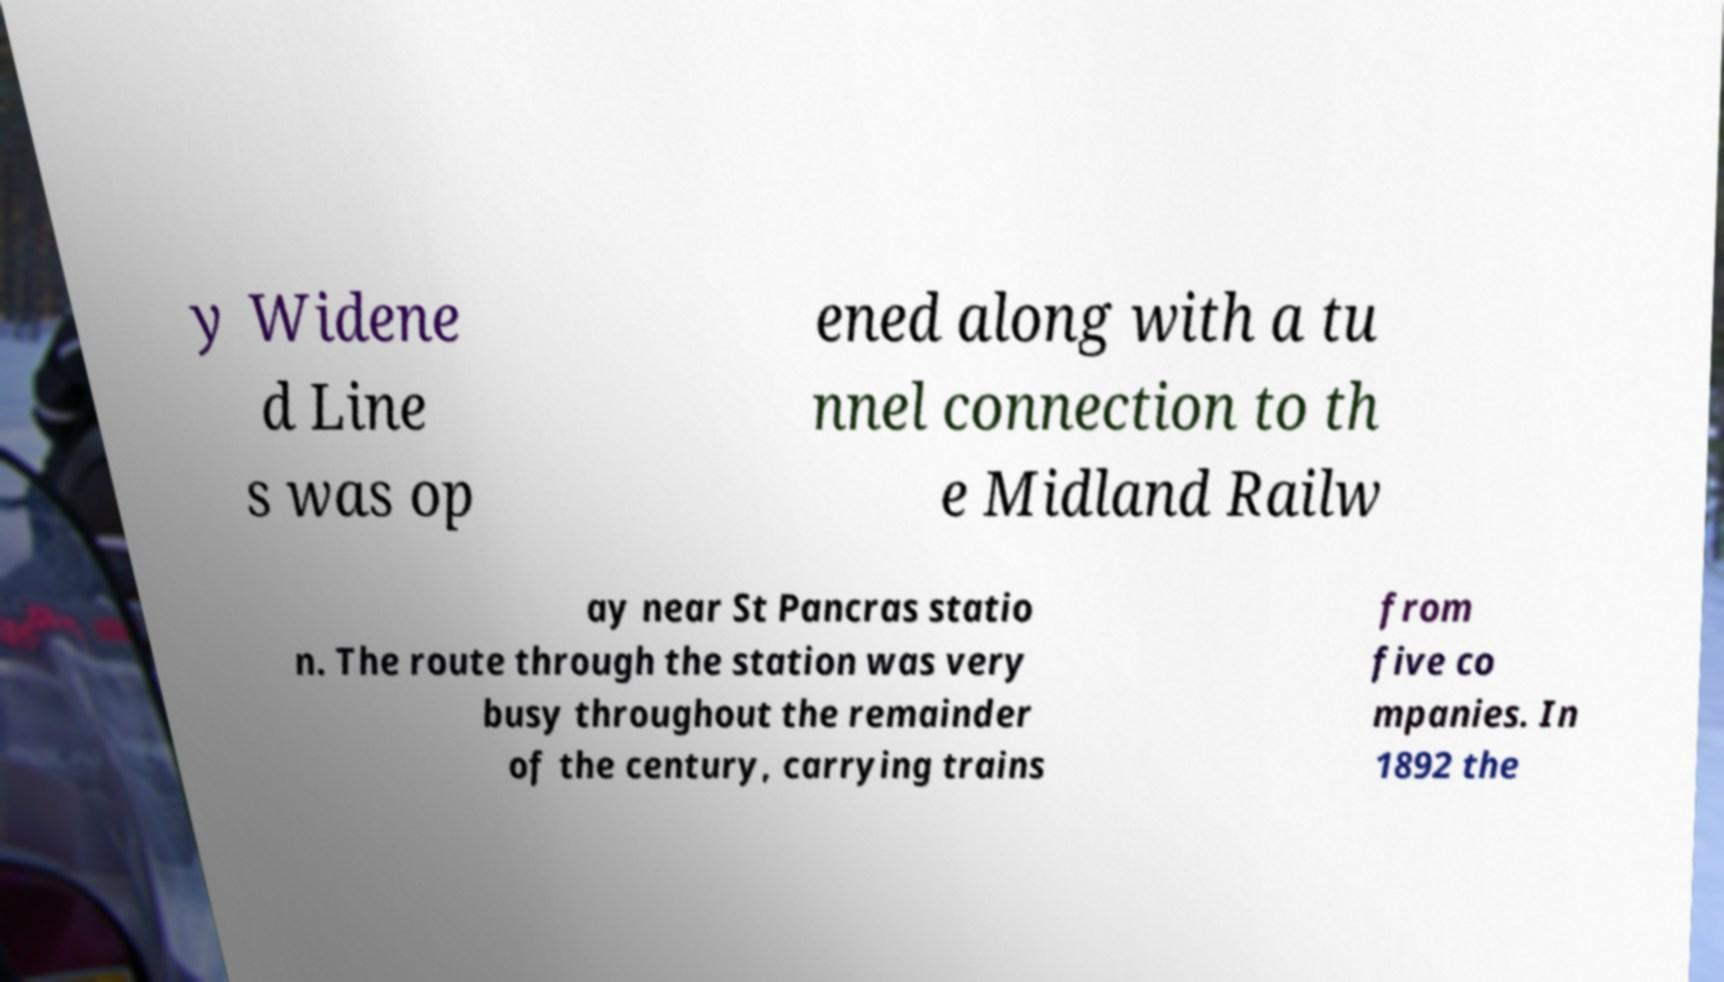Please read and relay the text visible in this image. What does it say? y Widene d Line s was op ened along with a tu nnel connection to th e Midland Railw ay near St Pancras statio n. The route through the station was very busy throughout the remainder of the century, carrying trains from five co mpanies. In 1892 the 